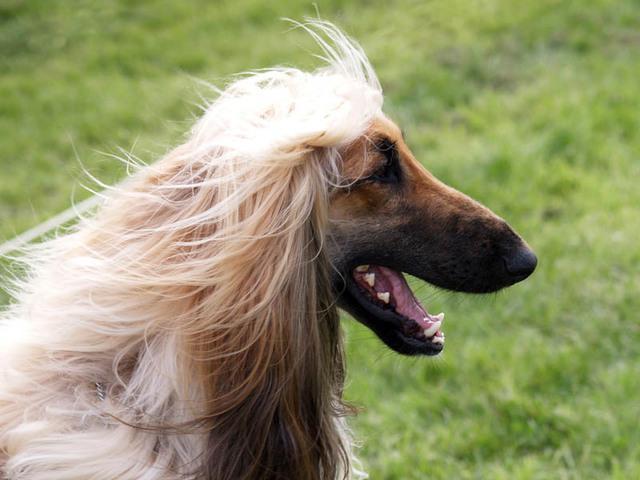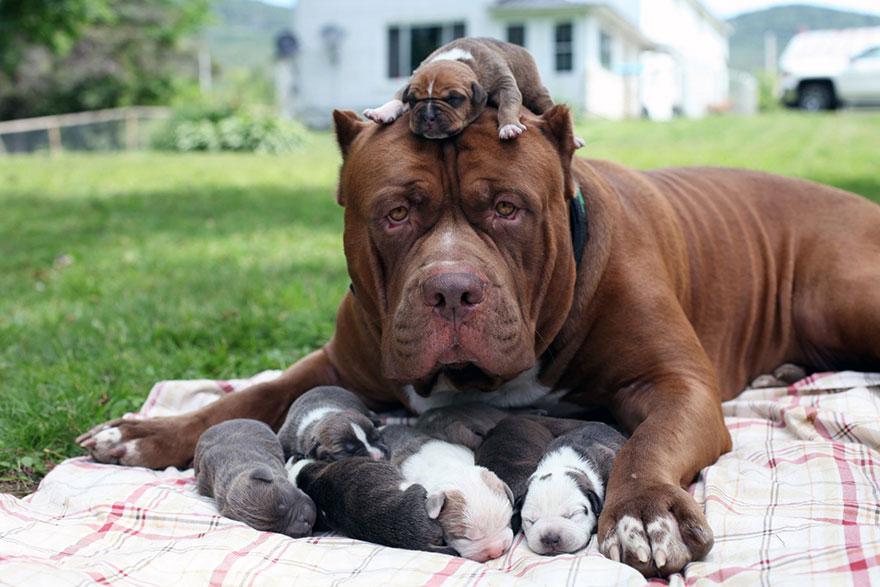The first image is the image on the left, the second image is the image on the right. Analyze the images presented: Is the assertion "The left image contains exactly two dogs." valid? Answer yes or no. No. The first image is the image on the left, the second image is the image on the right. Evaluate the accuracy of this statement regarding the images: "All hound dogs have their heads turned to the left, and at least two dogs have open mouths.". Is it true? Answer yes or no. No. 